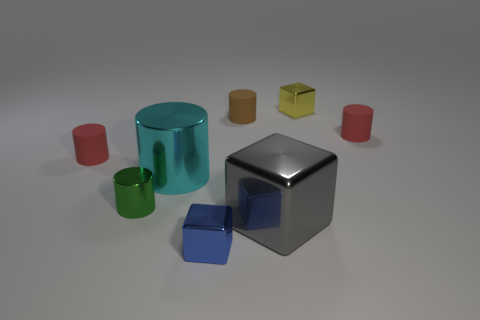What is the size of the shiny block that is behind the red rubber thing on the right side of the blue metallic object?
Provide a short and direct response. Small. Are any big cylinders visible?
Offer a very short reply. Yes. There is a metallic object in front of the large cube; what number of big cubes are on the left side of it?
Offer a very short reply. 0. There is a small metal object that is right of the blue metallic object; what is its shape?
Give a very brief answer. Cube. There is a large object that is left of the shiny cube that is left of the big metal object to the right of the tiny brown rubber object; what is it made of?
Keep it short and to the point. Metal. How many other objects are there of the same size as the brown rubber thing?
Give a very brief answer. 5. There is a small brown thing that is the same shape as the green thing; what is it made of?
Offer a very short reply. Rubber. What is the color of the big cylinder?
Offer a terse response. Cyan. What is the color of the tiny metal cube in front of the small red rubber thing to the left of the big cylinder?
Provide a short and direct response. Blue. Do the big cylinder and the small cube that is on the right side of the small brown rubber cylinder have the same color?
Offer a terse response. No. 